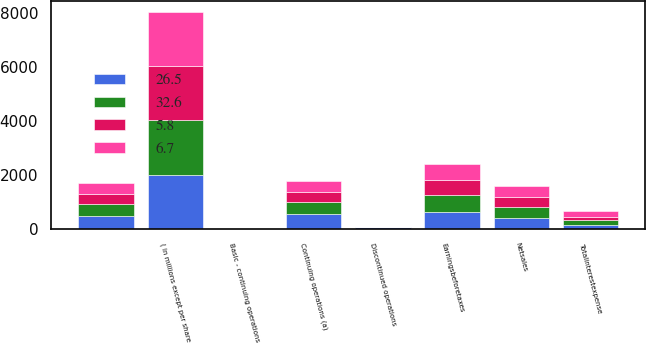Convert chart. <chart><loc_0><loc_0><loc_500><loc_500><stacked_bar_chart><ecel><fcel>( in millions except per share<fcel>Netsales<fcel>Totalinterestexpense<fcel>Earningsbeforetaxes<fcel>Continuing operations (a)<fcel>Discontinued operations<fcel>Unnamed: 7<fcel>Basic - continuing operations<nl><fcel>6.7<fcel>2012<fcel>396.8<fcel>194.9<fcel>595.6<fcel>406.3<fcel>2.8<fcel>403.5<fcel>2.63<nl><fcel>32.6<fcel>2011<fcel>396.8<fcel>177.1<fcel>659.8<fcel>446.3<fcel>2.3<fcel>444<fcel>2.7<nl><fcel>26.5<fcel>2010<fcel>396.8<fcel>158.2<fcel>606.4<fcel>542.9<fcel>74.9<fcel>468<fcel>3<nl><fcel>5.8<fcel>2009<fcel>396.8<fcel>117.2<fcel>536.6<fcel>390.1<fcel>2.2<fcel>387.9<fcel>2.08<nl></chart> 